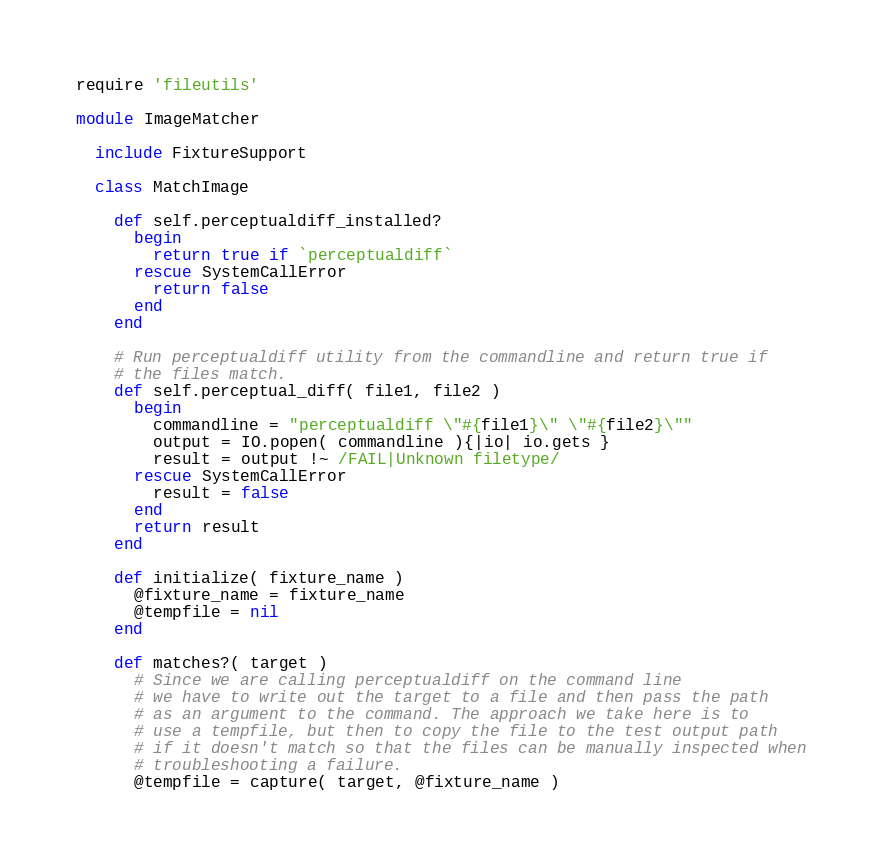Convert code to text. <code><loc_0><loc_0><loc_500><loc_500><_Ruby_>require 'fileutils'

module ImageMatcher
  
  include FixtureSupport
  
  class MatchImage
    
    def self.perceptualdiff_installed?
      begin
        return true if `perceptualdiff`
      rescue SystemCallError
        return false
      end
    end
    
    # Run perceptualdiff utility from the commandline and return true if 
    # the files match.
    def self.perceptual_diff( file1, file2 )      
      begin
        commandline = "perceptualdiff \"#{file1}\" \"#{file2}\""
        output = IO.popen( commandline ){|io| io.gets }        
        result = output !~ /FAIL|Unknown filetype/       
      rescue SystemCallError
        result = false
      end
      return result      
    end
    
    def initialize( fixture_name )
      @fixture_name = fixture_name
      @tempfile = nil
    end
    
    def matches?( target )      
      # Since we are calling perceptualdiff on the command line 
      # we have to write out the target to a file and then pass the path
      # as an argument to the command. The approach we take here is to 
      # use a tempfile, but then to copy the file to the test output path
      # if it doesn't match so that the files can be manually inspected when
      # troubleshooting a failure.
      @tempfile = capture( target, @fixture_name )</code> 